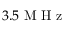<formula> <loc_0><loc_0><loc_500><loc_500>3 . 5 M H z</formula> 